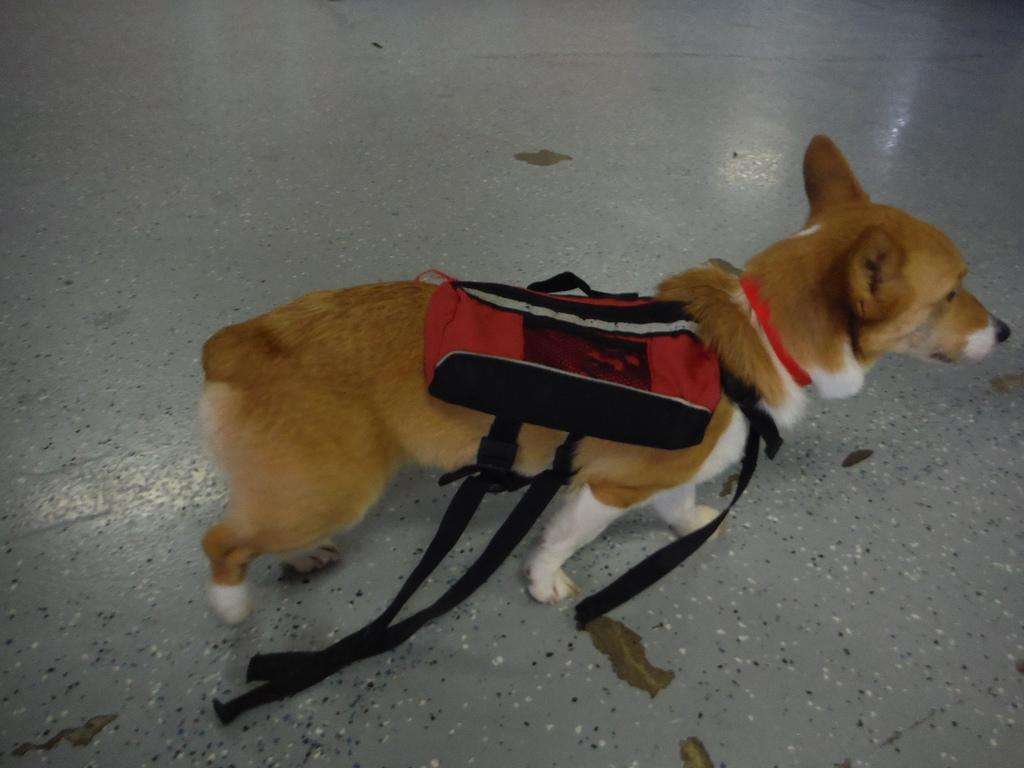What type of animal is in the image? There is a dog in the image. Can you describe the color of the dog? The dog has brown and white color. What is the dog wearing in the image? The dog is wearing a red and black color body belt. How many copies of the dog are present in the image? There is only one dog present in the image, so there are no copies. 